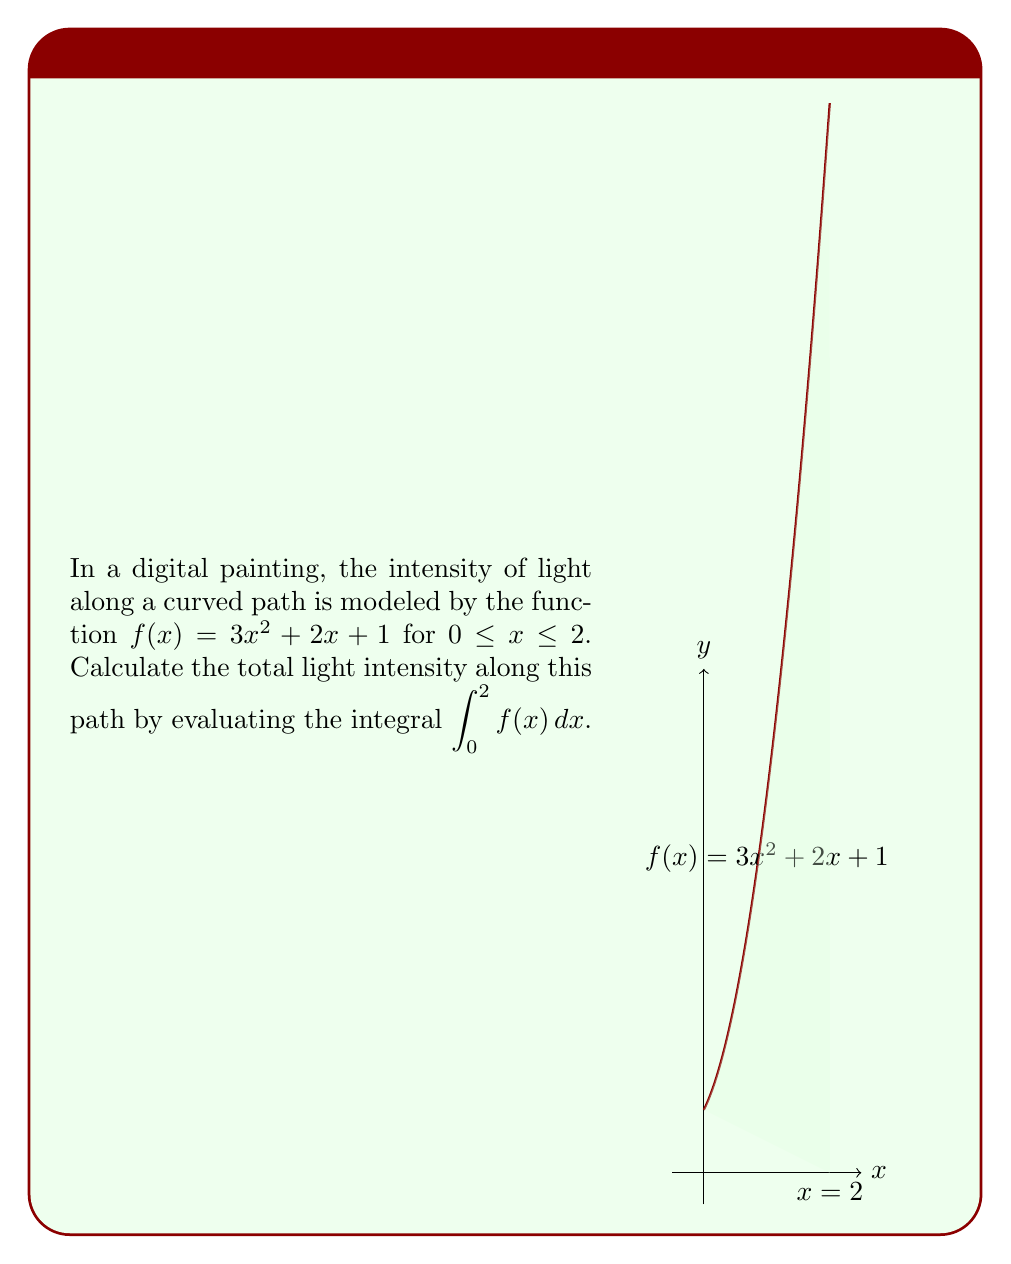Help me with this question. To evaluate the integral $\int_0^2 (3x^2 + 2x + 1) dx$, we'll use the following steps:

1) First, let's integrate the function term by term:

   $\int (3x^2 + 2x + 1) dx = x^3 + x^2 + x + C$

2) Now, we'll apply the Fundamental Theorem of Calculus:

   $\int_0^2 (3x^2 + 2x + 1) dx = [x^3 + x^2 + x]_0^2$

3) Evaluate the function at the upper and lower bounds:

   At $x = 2$: $2^3 + 2^2 + 2 = 8 + 4 + 2 = 14$
   At $x = 0$: $0^3 + 0^2 + 0 = 0$

4) Subtract the lower bound value from the upper bound value:

   $14 - 0 = 14$

Therefore, the total light intensity along the path is 14 units.
Answer: 14 